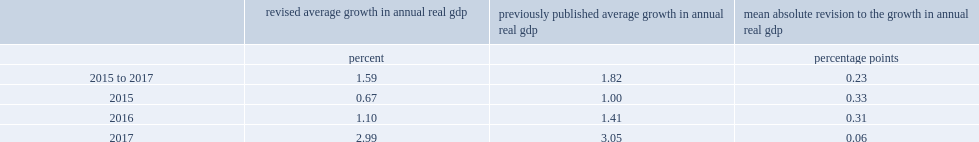How many the mean absolute percentage point was revision to the annual growth rate of real gdp for the 2015 to 2017 period? 0.23. 